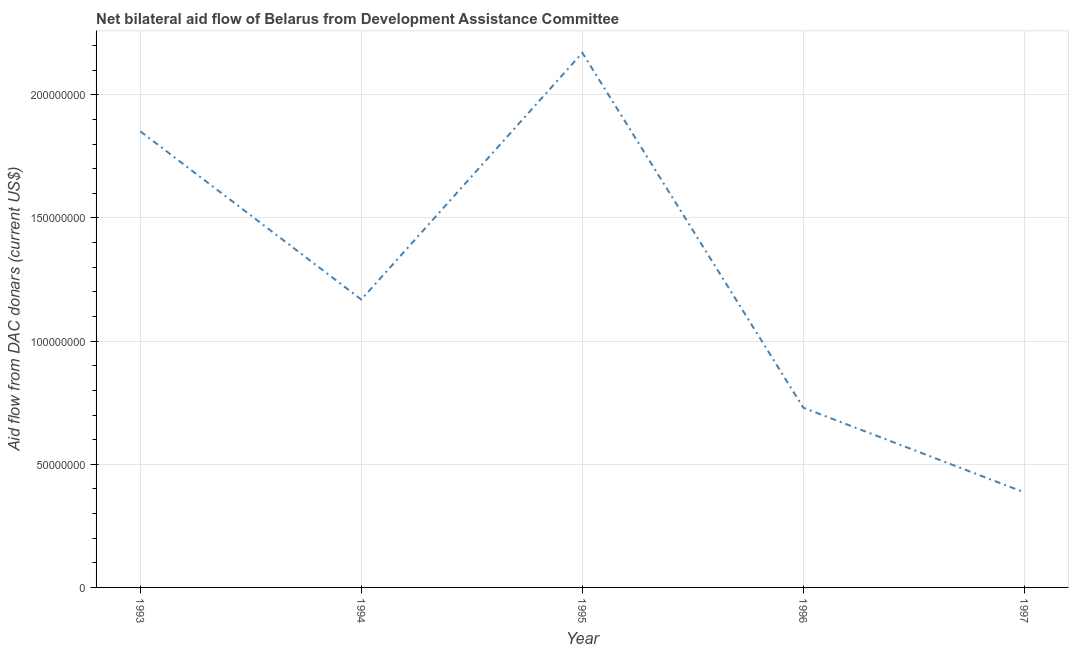What is the net bilateral aid flows from dac donors in 1997?
Make the answer very short. 3.86e+07. Across all years, what is the maximum net bilateral aid flows from dac donors?
Provide a short and direct response. 2.17e+08. Across all years, what is the minimum net bilateral aid flows from dac donors?
Your answer should be very brief. 3.86e+07. In which year was the net bilateral aid flows from dac donors minimum?
Offer a very short reply. 1997. What is the sum of the net bilateral aid flows from dac donors?
Your answer should be very brief. 6.31e+08. What is the difference between the net bilateral aid flows from dac donors in 1995 and 1996?
Make the answer very short. 1.44e+08. What is the average net bilateral aid flows from dac donors per year?
Provide a short and direct response. 1.26e+08. What is the median net bilateral aid flows from dac donors?
Provide a short and direct response. 1.17e+08. In how many years, is the net bilateral aid flows from dac donors greater than 30000000 US$?
Give a very brief answer. 5. Do a majority of the years between 1995 and 1994 (inclusive) have net bilateral aid flows from dac donors greater than 120000000 US$?
Provide a succinct answer. No. What is the ratio of the net bilateral aid flows from dac donors in 1993 to that in 1995?
Keep it short and to the point. 0.85. Is the net bilateral aid flows from dac donors in 1993 less than that in 1997?
Keep it short and to the point. No. What is the difference between the highest and the second highest net bilateral aid flows from dac donors?
Your answer should be very brief. 3.19e+07. What is the difference between the highest and the lowest net bilateral aid flows from dac donors?
Offer a terse response. 1.78e+08. Does the net bilateral aid flows from dac donors monotonically increase over the years?
Your response must be concise. No. How many lines are there?
Give a very brief answer. 1. Does the graph contain any zero values?
Give a very brief answer. No. Does the graph contain grids?
Give a very brief answer. Yes. What is the title of the graph?
Make the answer very short. Net bilateral aid flow of Belarus from Development Assistance Committee. What is the label or title of the Y-axis?
Keep it short and to the point. Aid flow from DAC donars (current US$). What is the Aid flow from DAC donars (current US$) in 1993?
Provide a succinct answer. 1.85e+08. What is the Aid flow from DAC donars (current US$) of 1994?
Provide a succinct answer. 1.17e+08. What is the Aid flow from DAC donars (current US$) in 1995?
Provide a short and direct response. 2.17e+08. What is the Aid flow from DAC donars (current US$) in 1996?
Provide a short and direct response. 7.30e+07. What is the Aid flow from DAC donars (current US$) in 1997?
Offer a terse response. 3.86e+07. What is the difference between the Aid flow from DAC donars (current US$) in 1993 and 1994?
Keep it short and to the point. 6.83e+07. What is the difference between the Aid flow from DAC donars (current US$) in 1993 and 1995?
Ensure brevity in your answer.  -3.19e+07. What is the difference between the Aid flow from DAC donars (current US$) in 1993 and 1996?
Offer a very short reply. 1.12e+08. What is the difference between the Aid flow from DAC donars (current US$) in 1993 and 1997?
Keep it short and to the point. 1.47e+08. What is the difference between the Aid flow from DAC donars (current US$) in 1994 and 1995?
Ensure brevity in your answer.  -1.00e+08. What is the difference between the Aid flow from DAC donars (current US$) in 1994 and 1996?
Your answer should be very brief. 4.39e+07. What is the difference between the Aid flow from DAC donars (current US$) in 1994 and 1997?
Your response must be concise. 7.83e+07. What is the difference between the Aid flow from DAC donars (current US$) in 1995 and 1996?
Give a very brief answer. 1.44e+08. What is the difference between the Aid flow from DAC donars (current US$) in 1995 and 1997?
Keep it short and to the point. 1.78e+08. What is the difference between the Aid flow from DAC donars (current US$) in 1996 and 1997?
Your response must be concise. 3.43e+07. What is the ratio of the Aid flow from DAC donars (current US$) in 1993 to that in 1994?
Offer a very short reply. 1.58. What is the ratio of the Aid flow from DAC donars (current US$) in 1993 to that in 1995?
Keep it short and to the point. 0.85. What is the ratio of the Aid flow from DAC donars (current US$) in 1993 to that in 1996?
Your answer should be very brief. 2.54. What is the ratio of the Aid flow from DAC donars (current US$) in 1993 to that in 1997?
Offer a terse response. 4.79. What is the ratio of the Aid flow from DAC donars (current US$) in 1994 to that in 1995?
Keep it short and to the point. 0.54. What is the ratio of the Aid flow from DAC donars (current US$) in 1994 to that in 1996?
Keep it short and to the point. 1.6. What is the ratio of the Aid flow from DAC donars (current US$) in 1994 to that in 1997?
Offer a terse response. 3.03. What is the ratio of the Aid flow from DAC donars (current US$) in 1995 to that in 1996?
Offer a very short reply. 2.98. What is the ratio of the Aid flow from DAC donars (current US$) in 1995 to that in 1997?
Give a very brief answer. 5.62. What is the ratio of the Aid flow from DAC donars (current US$) in 1996 to that in 1997?
Keep it short and to the point. 1.89. 